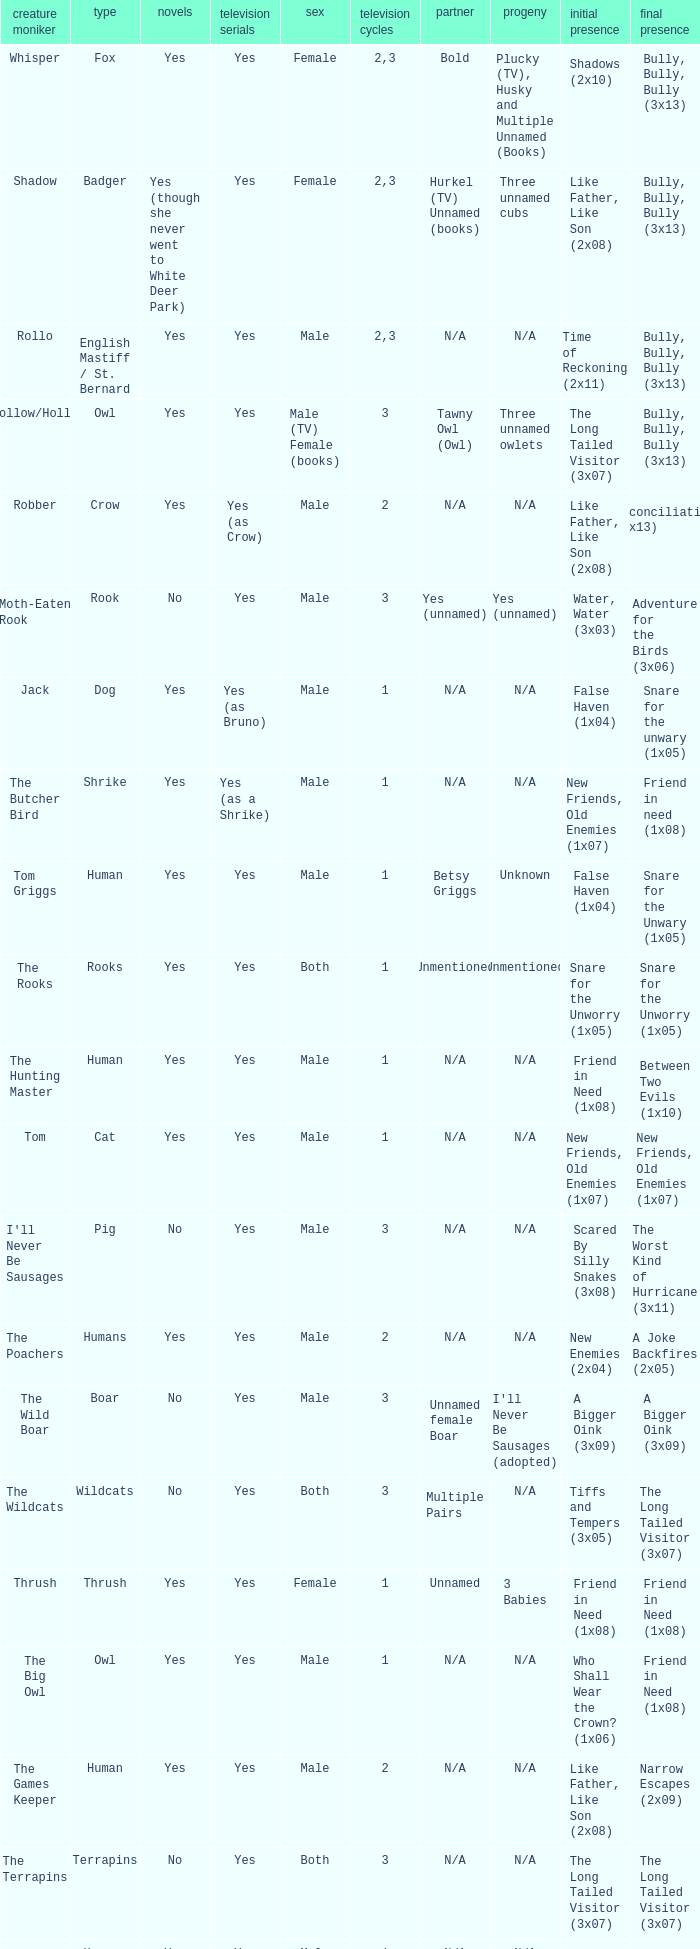What is the smallest season for a tv series with a yes and human was the species? 1.0. 